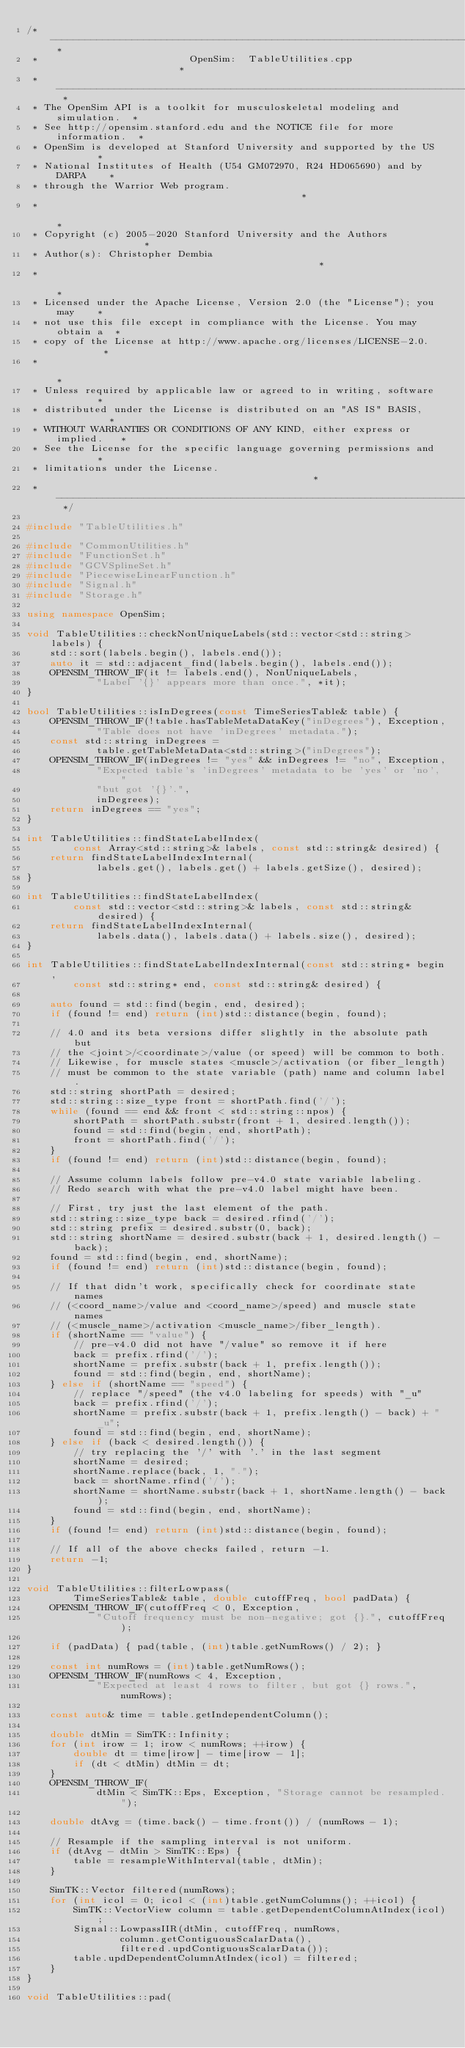<code> <loc_0><loc_0><loc_500><loc_500><_C++_>/* -------------------------------------------------------------------------- *
 *                          OpenSim:  TableUtilities.cpp                      *
 * -------------------------------------------------------------------------- *
 * The OpenSim API is a toolkit for musculoskeletal modeling and simulation.  *
 * See http://opensim.stanford.edu and the NOTICE file for more information.  *
 * OpenSim is developed at Stanford University and supported by the US        *
 * National Institutes of Health (U54 GM072970, R24 HD065690) and by DARPA    *
 * through the Warrior Web program.                                           *
 *                                                                            *
 * Copyright (c) 2005-2020 Stanford University and the Authors                *
 * Author(s): Christopher Dembia                                              *
 *                                                                            *
 * Licensed under the Apache License, Version 2.0 (the "License"); you may    *
 * not use this file except in compliance with the License. You may obtain a  *
 * copy of the License at http://www.apache.org/licenses/LICENSE-2.0.         *
 *                                                                            *
 * Unless required by applicable law or agreed to in writing, software        *
 * distributed under the License is distributed on an "AS IS" BASIS,          *
 * WITHOUT WARRANTIES OR CONDITIONS OF ANY KIND, either express or implied.   *
 * See the License for the specific language governing permissions and        *
 * limitations under the License.                                             *
 * -------------------------------------------------------------------------- */

#include "TableUtilities.h"

#include "CommonUtilities.h"
#include "FunctionSet.h"
#include "GCVSplineSet.h"
#include "PiecewiseLinearFunction.h"
#include "Signal.h"
#include "Storage.h"

using namespace OpenSim;

void TableUtilities::checkNonUniqueLabels(std::vector<std::string> labels) {
    std::sort(labels.begin(), labels.end());
    auto it = std::adjacent_find(labels.begin(), labels.end());
    OPENSIM_THROW_IF(it != labels.end(), NonUniqueLabels,
            "Label '{}' appears more than once.", *it);
}

bool TableUtilities::isInDegrees(const TimeSeriesTable& table) {
    OPENSIM_THROW_IF(!table.hasTableMetaDataKey("inDegrees"), Exception,
            "Table does not have 'inDegrees' metadata.");
    const std::string inDegrees =
            table.getTableMetaData<std::string>("inDegrees");
    OPENSIM_THROW_IF(inDegrees != "yes" && inDegrees != "no", Exception,
            "Expected table's 'inDegrees' metadata to be 'yes' or 'no', "
            "but got '{}'.",
            inDegrees);
    return inDegrees == "yes";
}

int TableUtilities::findStateLabelIndex(
        const Array<std::string>& labels, const std::string& desired) {
    return findStateLabelIndexInternal(
            labels.get(), labels.get() + labels.getSize(), desired);
}

int TableUtilities::findStateLabelIndex(
        const std::vector<std::string>& labels, const std::string& desired) {
    return findStateLabelIndexInternal(
            labels.data(), labels.data() + labels.size(), desired);
}

int TableUtilities::findStateLabelIndexInternal(const std::string* begin,
        const std::string* end, const std::string& desired) {

    auto found = std::find(begin, end, desired);
    if (found != end) return (int)std::distance(begin, found);

    // 4.0 and its beta versions differ slightly in the absolute path but
    // the <joint>/<coordinate>/value (or speed) will be common to both.
    // Likewise, for muscle states <muscle>/activation (or fiber_length)
    // must be common to the state variable (path) name and column label.
    std::string shortPath = desired;
    std::string::size_type front = shortPath.find('/');
    while (found == end && front < std::string::npos) {
        shortPath = shortPath.substr(front + 1, desired.length());
        found = std::find(begin, end, shortPath);
        front = shortPath.find('/');
    }
    if (found != end) return (int)std::distance(begin, found);

    // Assume column labels follow pre-v4.0 state variable labeling.
    // Redo search with what the pre-v4.0 label might have been.

    // First, try just the last element of the path.
    std::string::size_type back = desired.rfind('/');
    std::string prefix = desired.substr(0, back);
    std::string shortName = desired.substr(back + 1, desired.length() - back);
    found = std::find(begin, end, shortName);
    if (found != end) return (int)std::distance(begin, found);

    // If that didn't work, specifically check for coordinate state names
    // (<coord_name>/value and <coord_name>/speed) and muscle state names
    // (<muscle_name>/activation <muscle_name>/fiber_length).
    if (shortName == "value") {
        // pre-v4.0 did not have "/value" so remove it if here
        back = prefix.rfind('/');
        shortName = prefix.substr(back + 1, prefix.length());
        found = std::find(begin, end, shortName);
    } else if (shortName == "speed") {
        // replace "/speed" (the v4.0 labeling for speeds) with "_u"
        back = prefix.rfind('/');
        shortName = prefix.substr(back + 1, prefix.length() - back) + "_u";
        found = std::find(begin, end, shortName);
    } else if (back < desired.length()) {
        // try replacing the '/' with '.' in the last segment
        shortName = desired;
        shortName.replace(back, 1, ".");
        back = shortName.rfind('/');
        shortName = shortName.substr(back + 1, shortName.length() - back);
        found = std::find(begin, end, shortName);
    }
    if (found != end) return (int)std::distance(begin, found);

    // If all of the above checks failed, return -1.
    return -1;
}

void TableUtilities::filterLowpass(
        TimeSeriesTable& table, double cutoffFreq, bool padData) {
    OPENSIM_THROW_IF(cutoffFreq < 0, Exception,
            "Cutoff frequency must be non-negative; got {}.", cutoffFreq);

    if (padData) { pad(table, (int)table.getNumRows() / 2); }

    const int numRows = (int)table.getNumRows();
    OPENSIM_THROW_IF(numRows < 4, Exception,
            "Expected at least 4 rows to filter, but got {} rows.", numRows);

    const auto& time = table.getIndependentColumn();

    double dtMin = SimTK::Infinity;
    for (int irow = 1; irow < numRows; ++irow) {
        double dt = time[irow] - time[irow - 1];
        if (dt < dtMin) dtMin = dt;
    }
    OPENSIM_THROW_IF(
            dtMin < SimTK::Eps, Exception, "Storage cannot be resampled.");

    double dtAvg = (time.back() - time.front()) / (numRows - 1);

    // Resample if the sampling interval is not uniform.
    if (dtAvg - dtMin > SimTK::Eps) {
        table = resampleWithInterval(table, dtMin);
    }

    SimTK::Vector filtered(numRows);
    for (int icol = 0; icol < (int)table.getNumColumns(); ++icol) {
        SimTK::VectorView column = table.getDependentColumnAtIndex(icol);
        Signal::LowpassIIR(dtMin, cutoffFreq, numRows,
                column.getContiguousScalarData(),
                filtered.updContiguousScalarData());
        table.updDependentColumnAtIndex(icol) = filtered;
    }
}

void TableUtilities::pad(</code> 